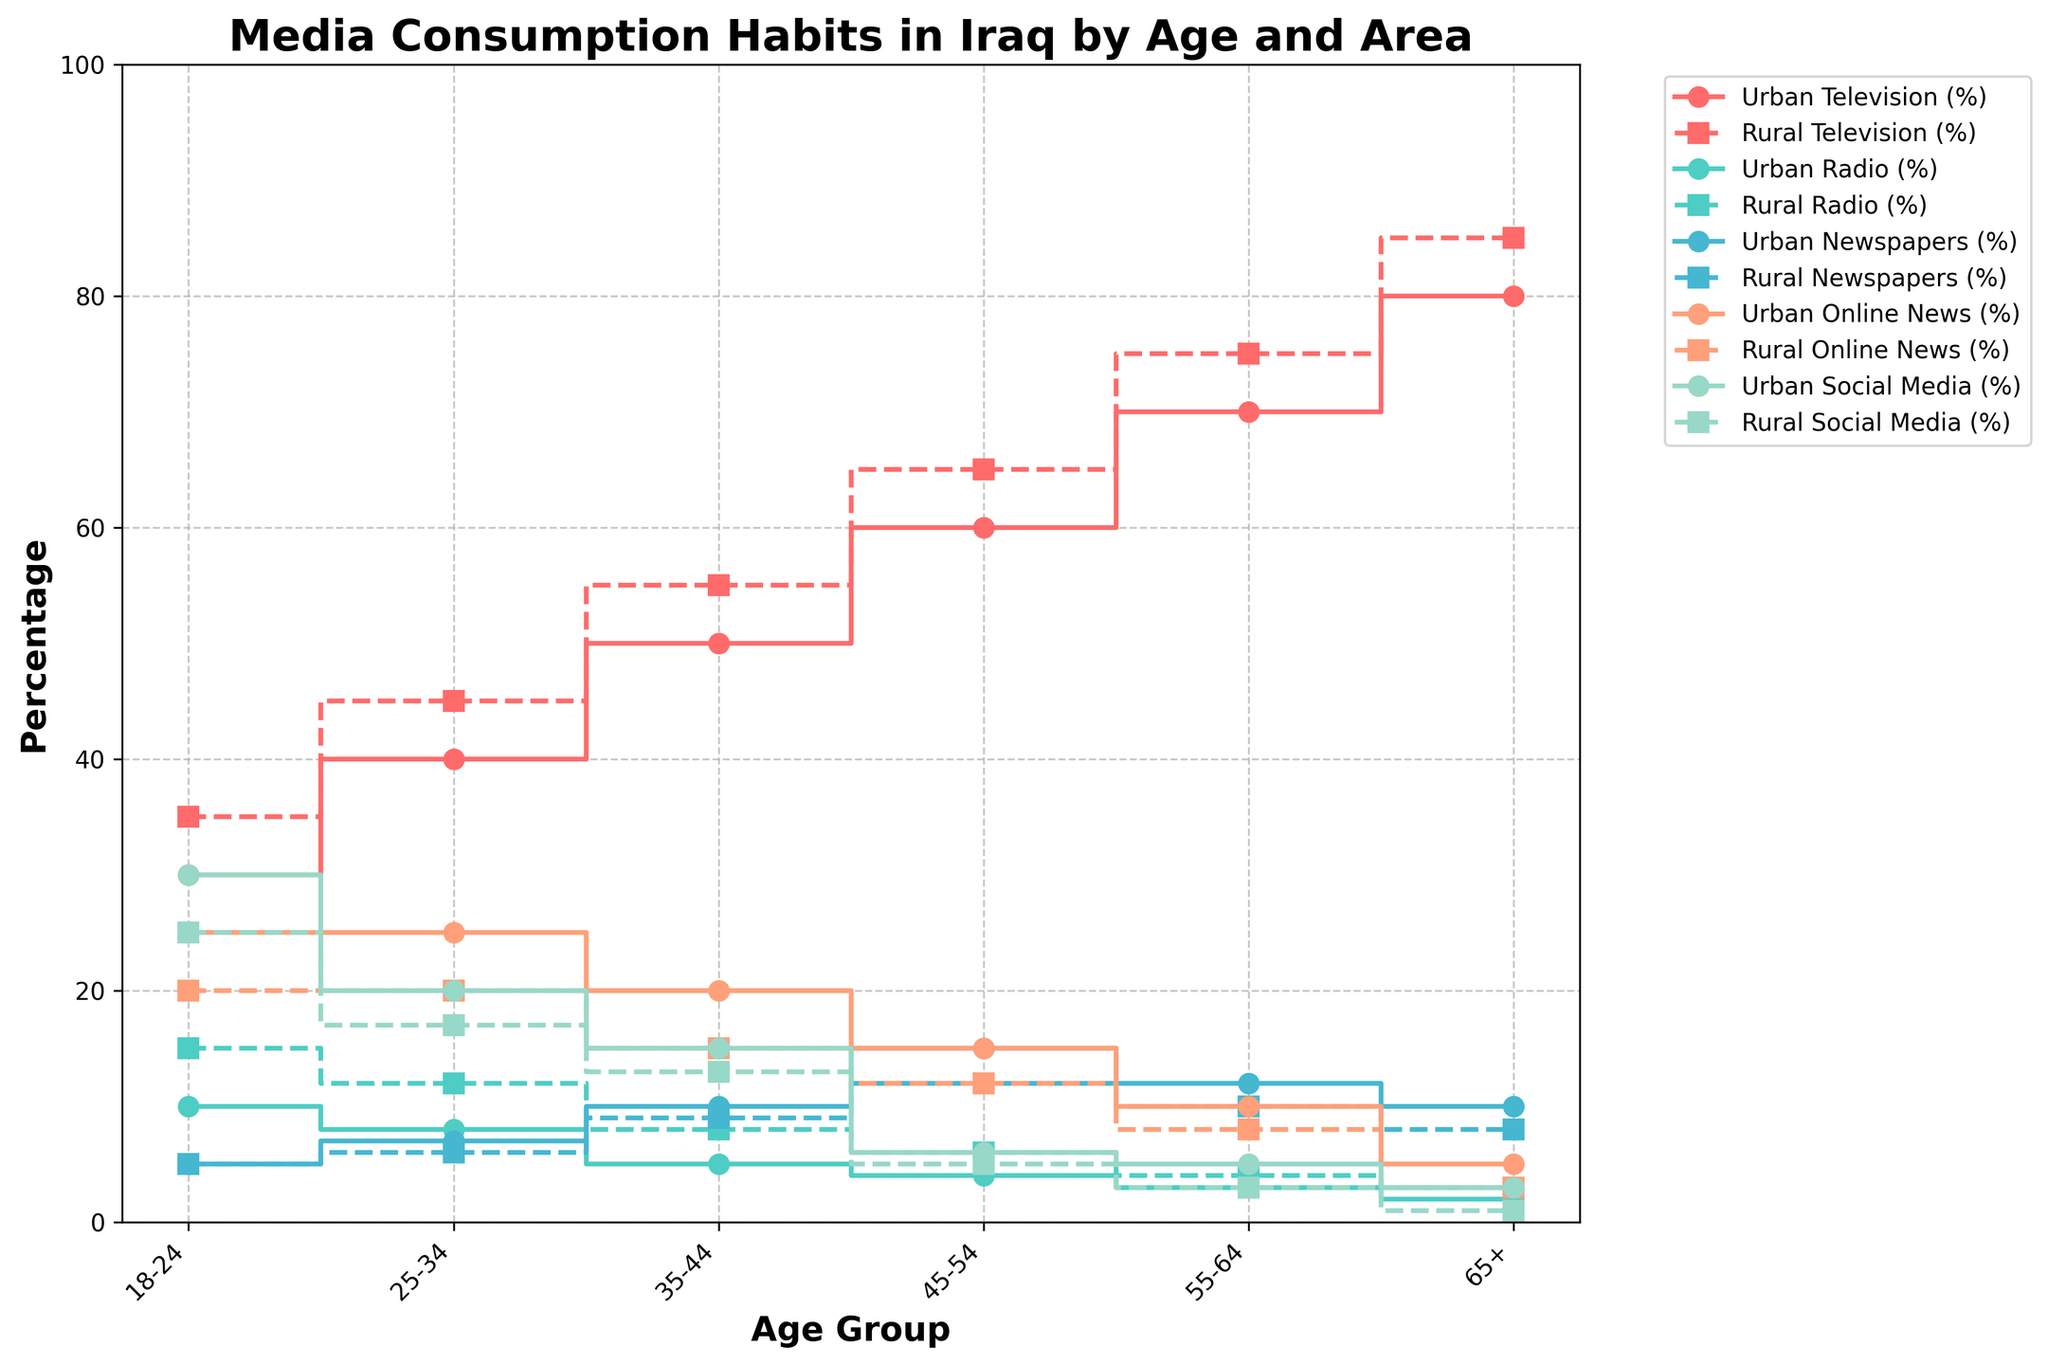What is the title of the plot? The title is usually positioned at the top center of the figure and often summarizes the content.
Answer: Media Consumption Habits in Iraq by Age and Area What is the percentage of television consumption for urban areas for the age group 35-44? The urban television consumption value for the age group 35-44 can be identified by locating the 35-44 age category and tracing the connected line to the "Television" category.
Answer: 50% How does social media consumption for the 18-24 age group compare between urban and rural areas? Check the social media consumption for the 18-24 group in both urban and rural areas and compare their values.
Answer: Urban: 30%, Rural: 25% For which age group and area is radio consumption highest? Locate the highest value in the radio category across all the age groups and both urban and rural areas.
Answer: 18-24 Rural: 15% What can you infer about newspaper consumption trends as age increases in urban areas? Trace the newspaper consumption values across increasing age groups in urban areas and observe any consistent patterns or trends.
Answer: Newspaper consumption generally increases as age increases What is the difference in television consumption between the 45-54 and 55-64 age groups in rural areas? Locate the television consumption values for the 45-54 and 55-64 age groups in rural areas and subtract the former from the latter.
Answer: 10% Compare online news consumption for those aged 25-34 in urban and rural areas. Identify the online news consumption values for the 25-34 age group in both urban and rural settings and compare them.
Answer: Both are 25% Which age group has the lowest social media consumption in urban areas? Find the age group with the minimum value for social media consumption among all urban age groups.
Answer: 65+ Urban How does television consumption in rural areas change from the 18-24 group to the 65+ group? Observe the step plot for rural television consumption starting from 18-24 to 65+ and note the changes.
Answer: Increases from 35% to 85% What is the average newspaper consumption in urban areas across all age groups? Sum the newspaper consumption values for all urban age groups and divide by the number of age groups.
Answer: (5+7+10+15+12+10)/6 = 9.833% 